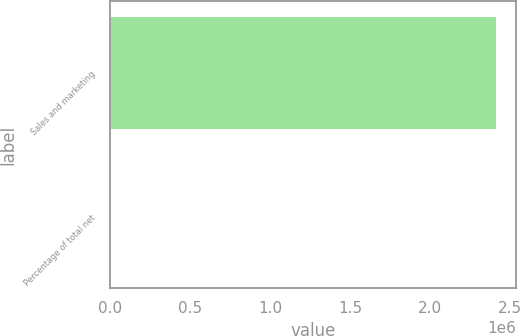Convert chart. <chart><loc_0><loc_0><loc_500><loc_500><bar_chart><fcel>Sales and marketing<fcel>Percentage of total net<nl><fcel>2.41526e+06<fcel>41<nl></chart> 